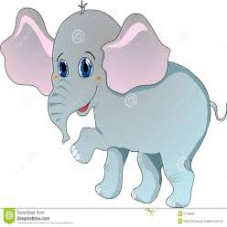What emotions does the elephant seem to convey through its expression and posture? The cartoon elephant displays a joyful and friendly demeanor. Its eyes are wide and bright, enhancing its approachable appearance. Additionally, the upward curve of the trunk, often likened to a smile in cartoon interpretations, along with its playful stance, suggests positivity and cheerfulness. These elements are crafted to engage a viewer, particularly younger audiences, conveying feelings of happiness and lightheartedness. 